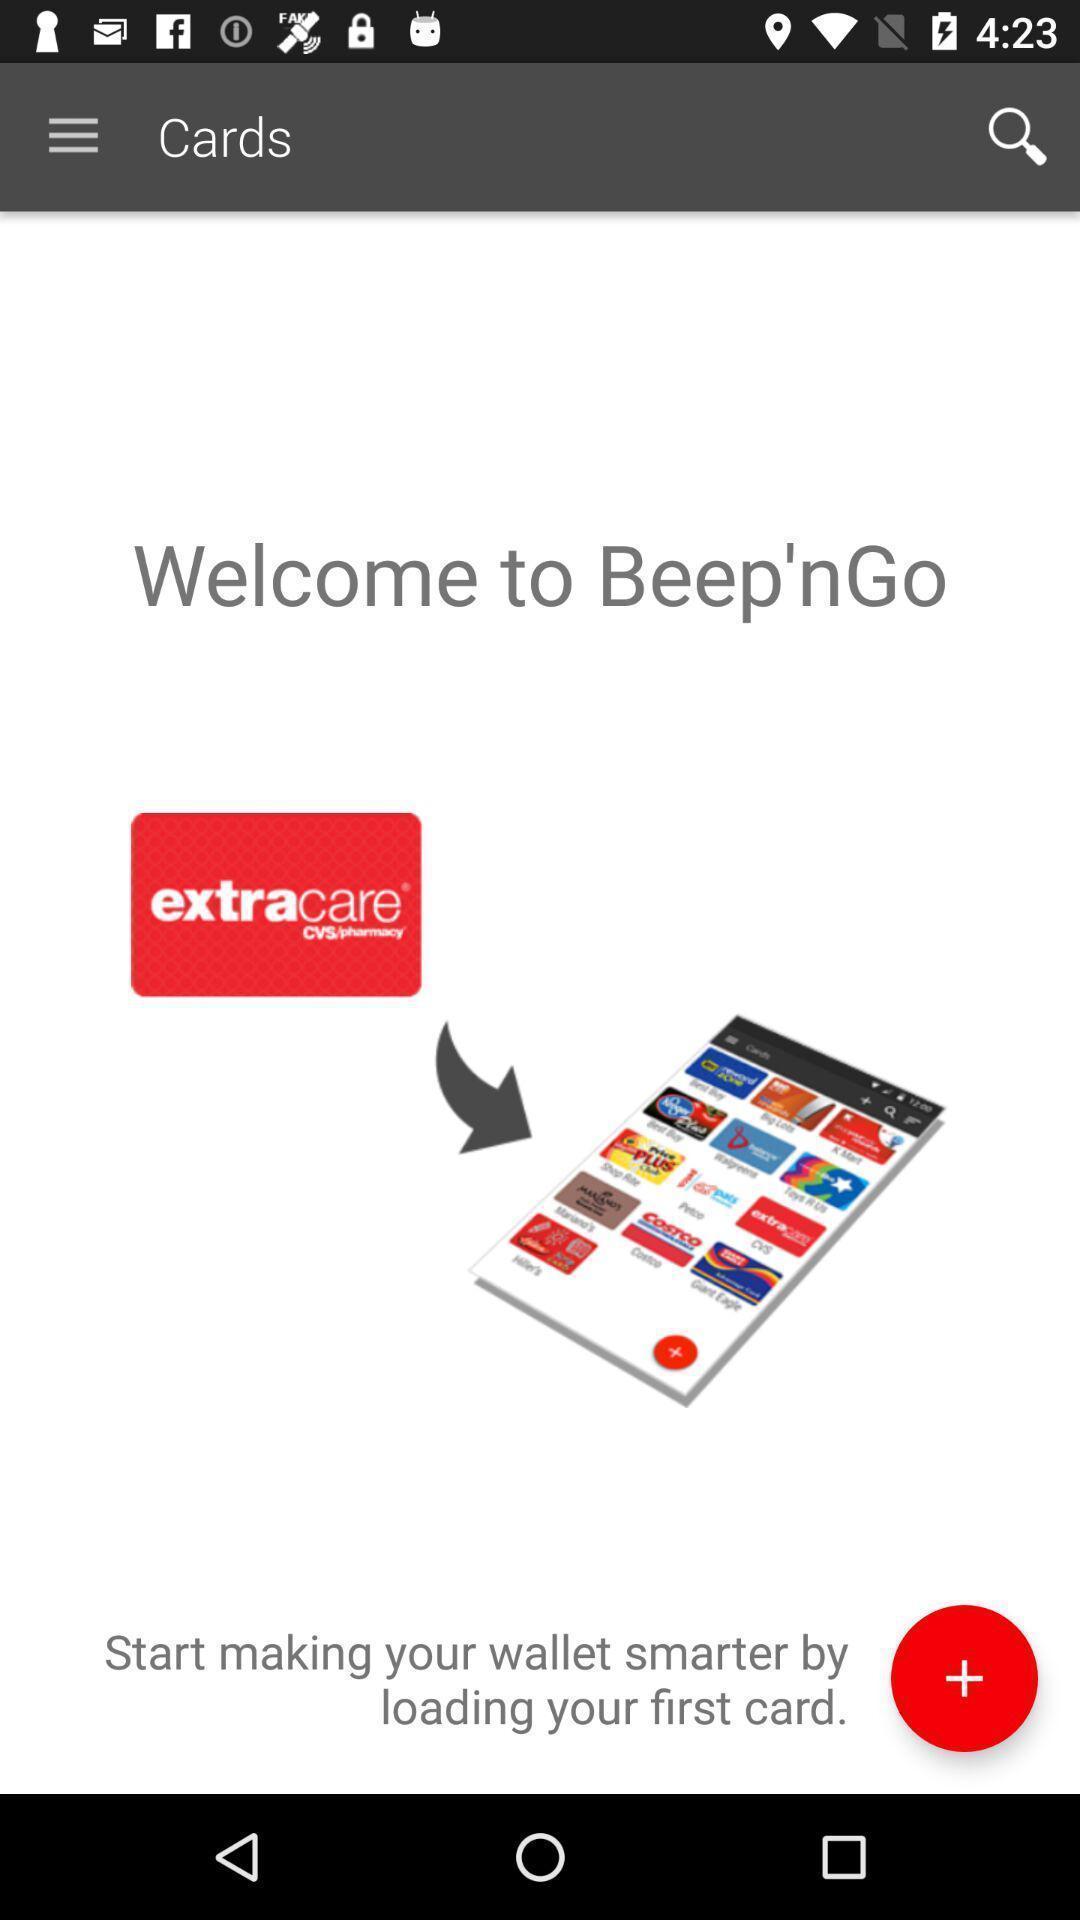What is the overall content of this screenshot? Welcome page of the financial app. 